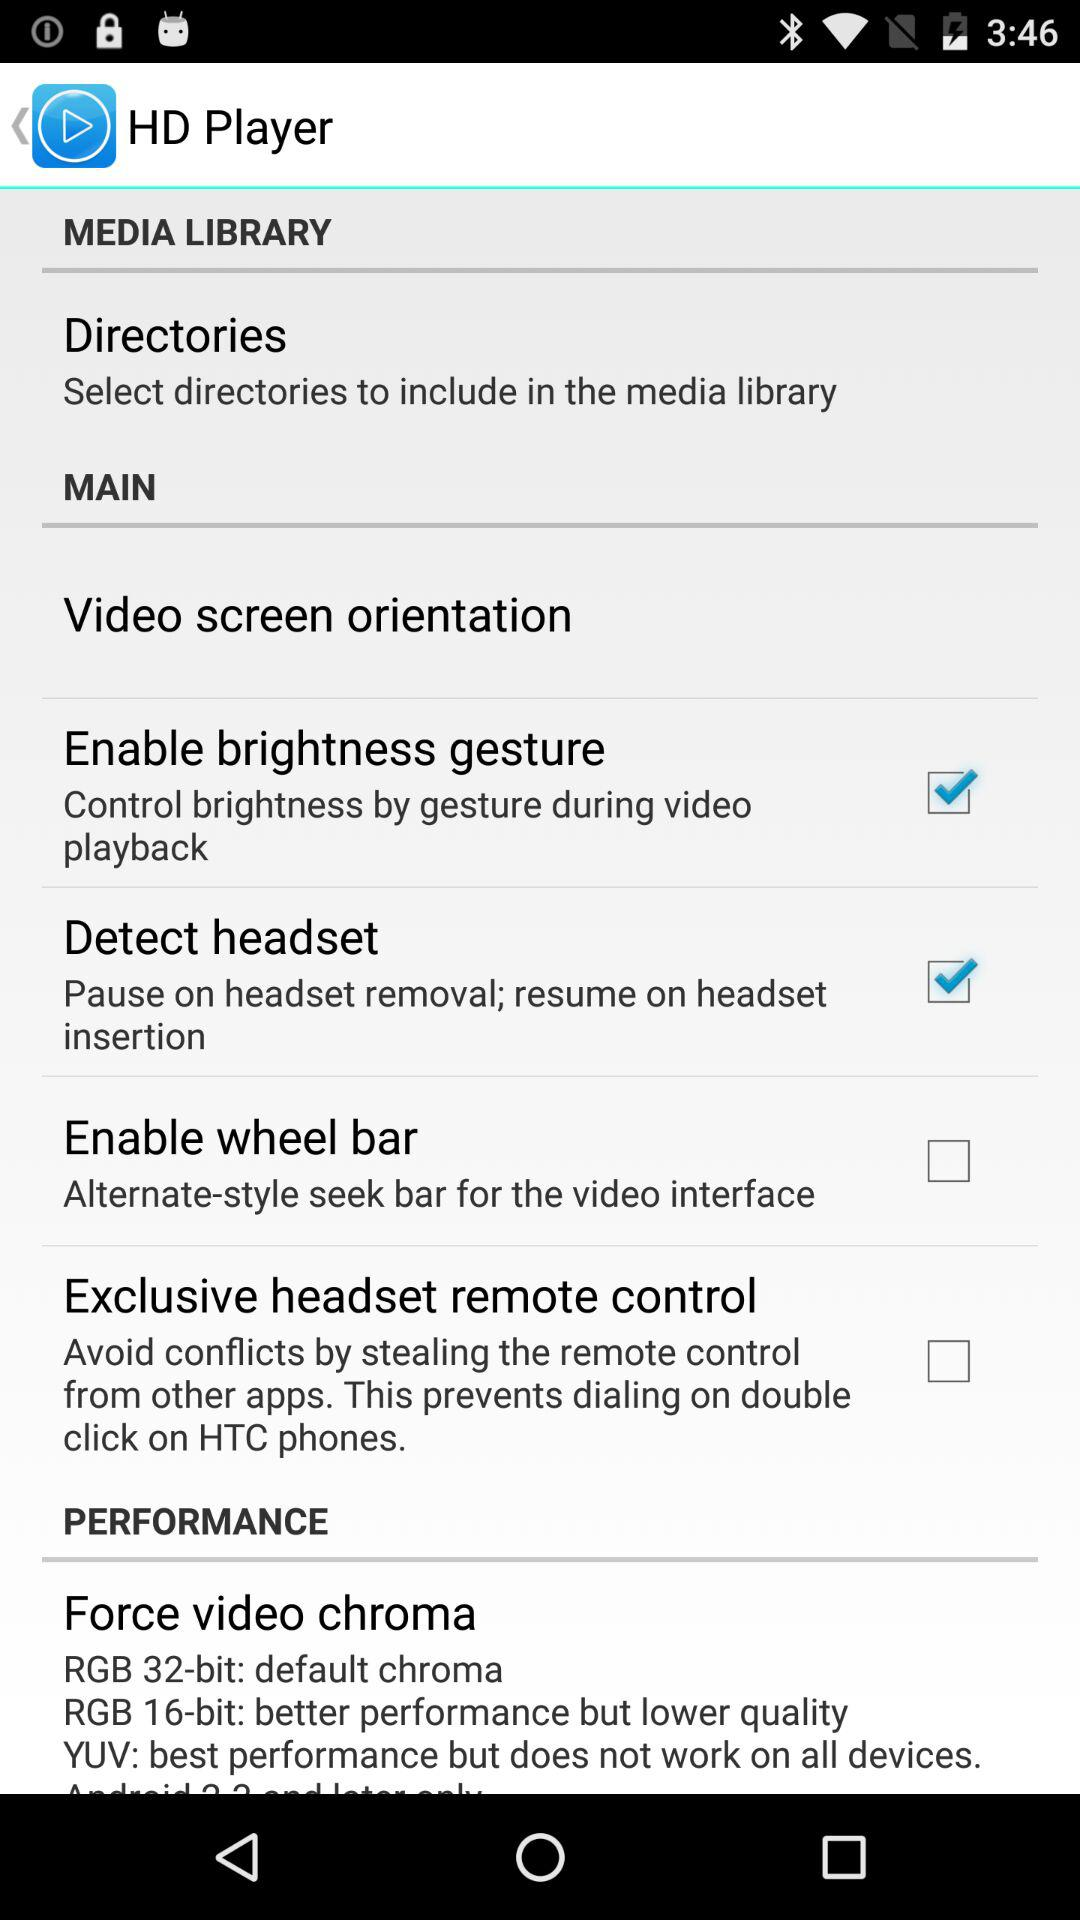What's the status of the "Detect headset"? The status is "on". 